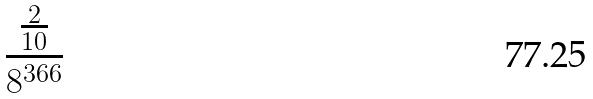<formula> <loc_0><loc_0><loc_500><loc_500>\frac { \frac { 2 } { 1 0 } } { 8 ^ { 3 6 6 } }</formula> 